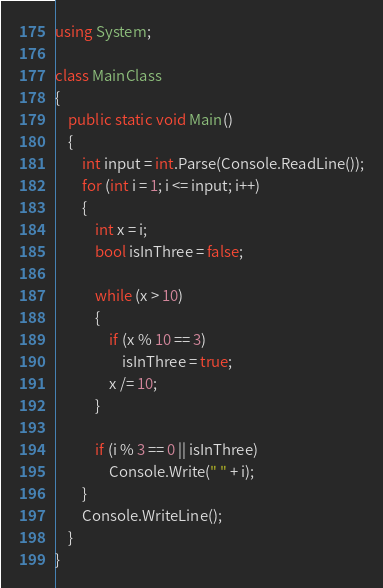Convert code to text. <code><loc_0><loc_0><loc_500><loc_500><_C#_>using System;

class MainClass
{
    public static void Main()
    {
        int input = int.Parse(Console.ReadLine());
        for (int i = 1; i <= input; i++)
        {
            int x = i;
            bool isInThree = false;

            while (x > 10)
            {
                if (x % 10 == 3)
                    isInThree = true;
                x /= 10;
            }

            if (i % 3 == 0 || isInThree)
                Console.Write(" " + i);
        }
        Console.WriteLine();
    }
}</code> 